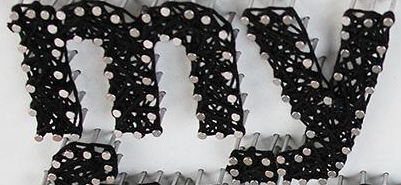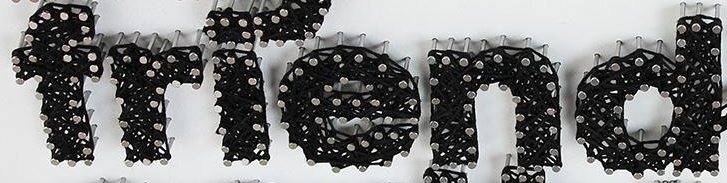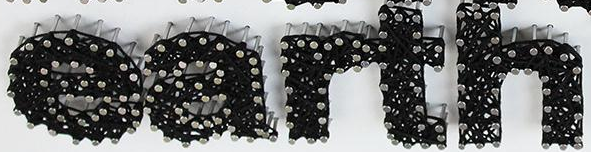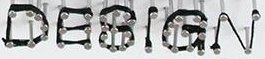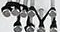Read the text from these images in sequence, separated by a semicolon. my; friend; earth; DESIGN; TM 